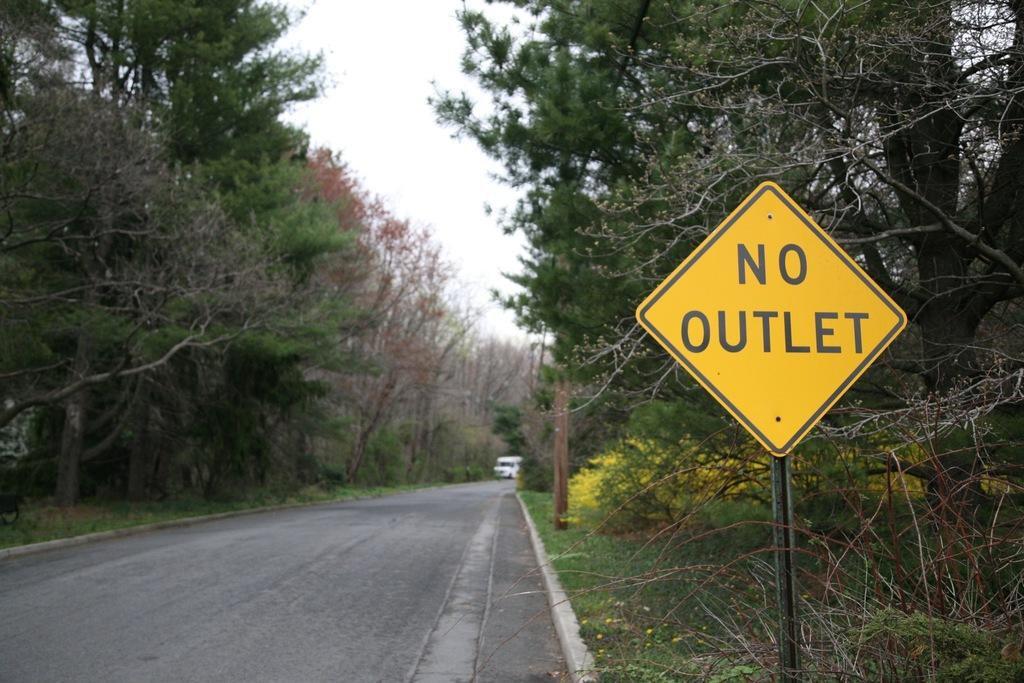<image>
Give a short and clear explanation of the subsequent image. A yellow sign on the side of the street says no outlet. 